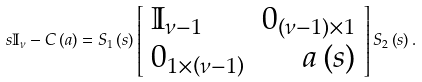<formula> <loc_0><loc_0><loc_500><loc_500>s \mathbb { I } _ { \nu } - C \left ( a \right ) = S _ { 1 } \left ( s \right ) \left [ \begin{array} { l r } \mathbb { I } _ { \nu - 1 } & 0 _ { \left ( \nu - 1 \right ) \times 1 } \\ 0 _ { 1 \times \left ( \nu - 1 \right ) } & a \left ( s \right ) \end{array} \right ] S _ { 2 } \left ( s \right ) .</formula> 